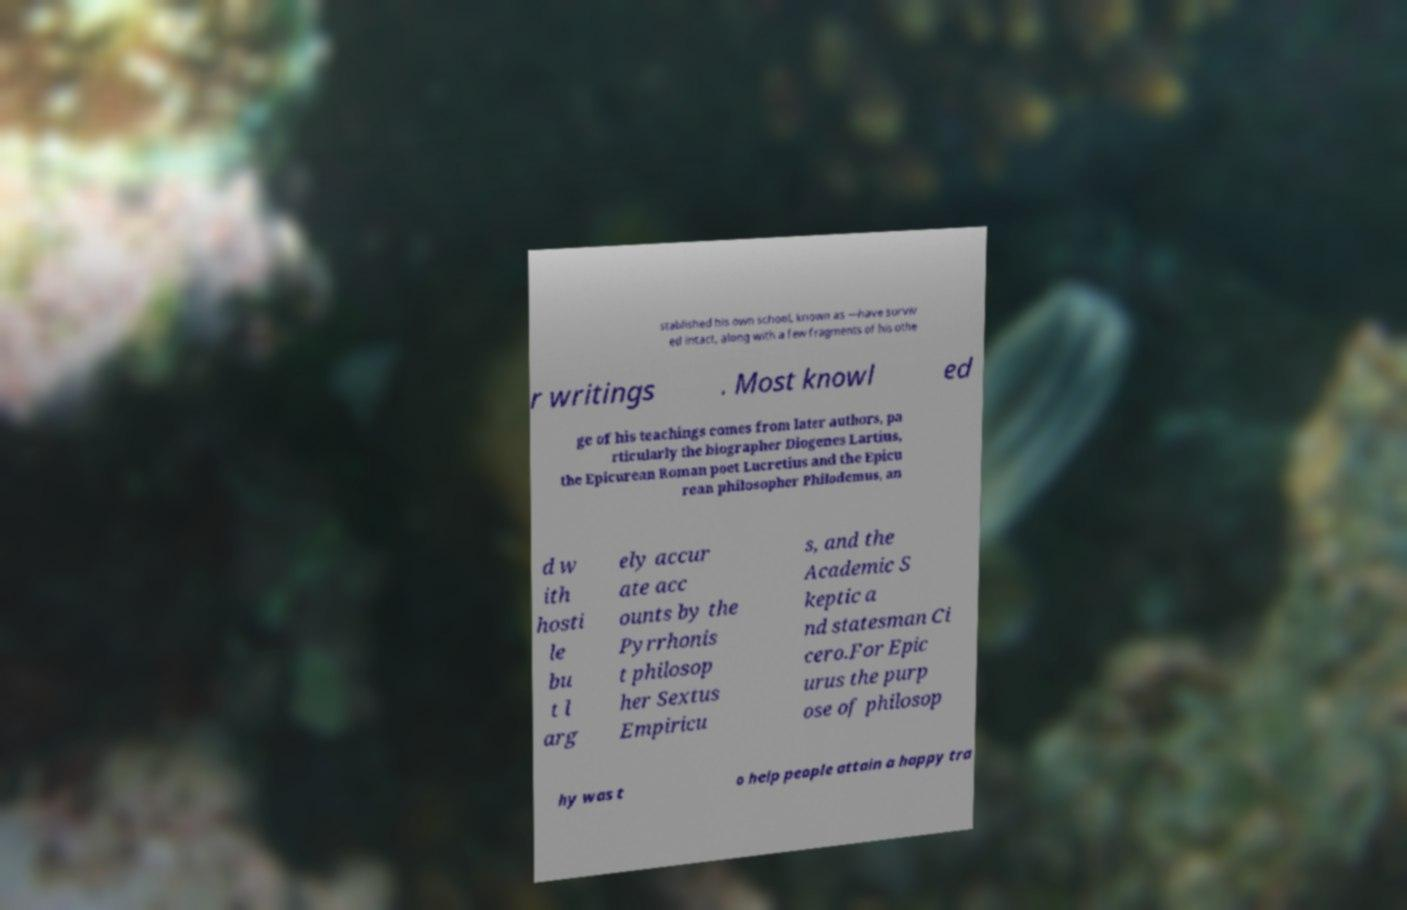Could you extract and type out the text from this image? stablished his own school, known as —have surviv ed intact, along with a few fragments of his othe r writings . Most knowl ed ge of his teachings comes from later authors, pa rticularly the biographer Diogenes Lartius, the Epicurean Roman poet Lucretius and the Epicu rean philosopher Philodemus, an d w ith hosti le bu t l arg ely accur ate acc ounts by the Pyrrhonis t philosop her Sextus Empiricu s, and the Academic S keptic a nd statesman Ci cero.For Epic urus the purp ose of philosop hy was t o help people attain a happy tra 